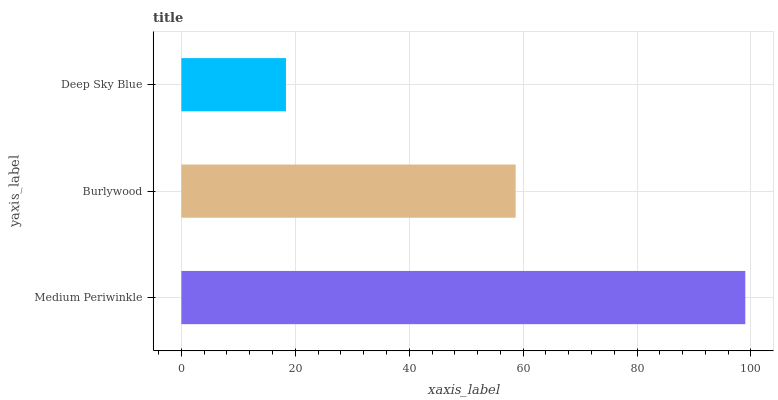Is Deep Sky Blue the minimum?
Answer yes or no. Yes. Is Medium Periwinkle the maximum?
Answer yes or no. Yes. Is Burlywood the minimum?
Answer yes or no. No. Is Burlywood the maximum?
Answer yes or no. No. Is Medium Periwinkle greater than Burlywood?
Answer yes or no. Yes. Is Burlywood less than Medium Periwinkle?
Answer yes or no. Yes. Is Burlywood greater than Medium Periwinkle?
Answer yes or no. No. Is Medium Periwinkle less than Burlywood?
Answer yes or no. No. Is Burlywood the high median?
Answer yes or no. Yes. Is Burlywood the low median?
Answer yes or no. Yes. Is Deep Sky Blue the high median?
Answer yes or no. No. Is Deep Sky Blue the low median?
Answer yes or no. No. 